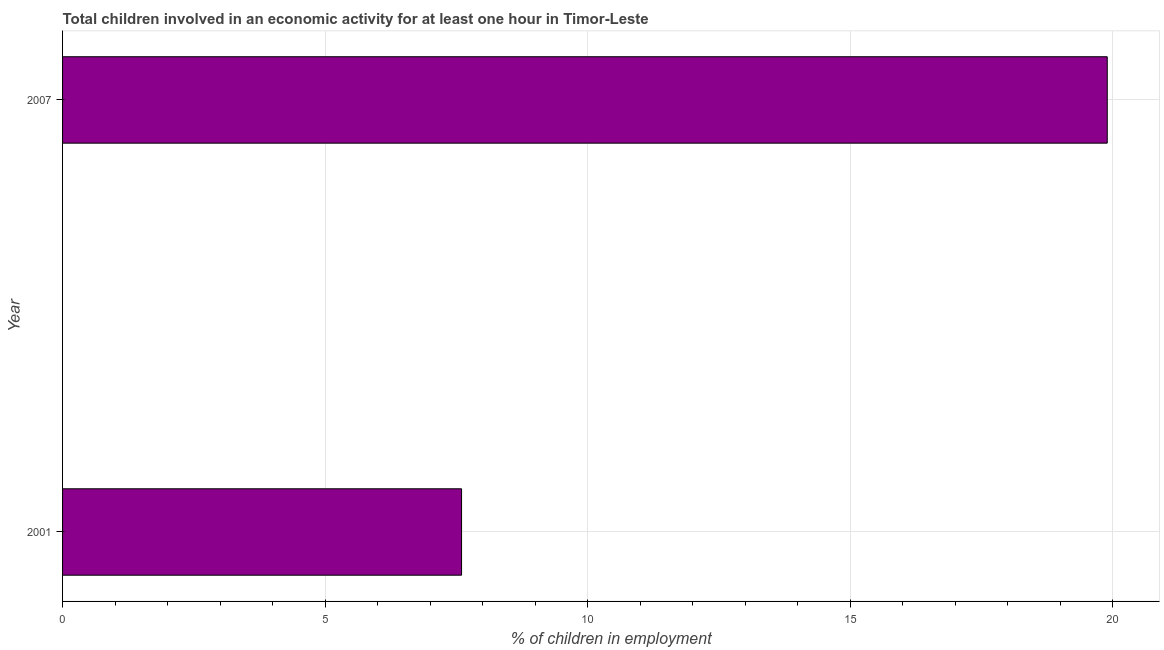What is the title of the graph?
Keep it short and to the point. Total children involved in an economic activity for at least one hour in Timor-Leste. What is the label or title of the X-axis?
Offer a very short reply. % of children in employment. Across all years, what is the minimum percentage of children in employment?
Your response must be concise. 7.6. In which year was the percentage of children in employment minimum?
Your response must be concise. 2001. What is the sum of the percentage of children in employment?
Offer a terse response. 27.5. What is the average percentage of children in employment per year?
Offer a very short reply. 13.75. What is the median percentage of children in employment?
Your answer should be compact. 13.75. In how many years, is the percentage of children in employment greater than 11 %?
Make the answer very short. 1. Do a majority of the years between 2001 and 2007 (inclusive) have percentage of children in employment greater than 1 %?
Offer a terse response. Yes. What is the ratio of the percentage of children in employment in 2001 to that in 2007?
Your response must be concise. 0.38. In how many years, is the percentage of children in employment greater than the average percentage of children in employment taken over all years?
Keep it short and to the point. 1. How many bars are there?
Provide a succinct answer. 2. What is the ratio of the % of children in employment in 2001 to that in 2007?
Give a very brief answer. 0.38. 